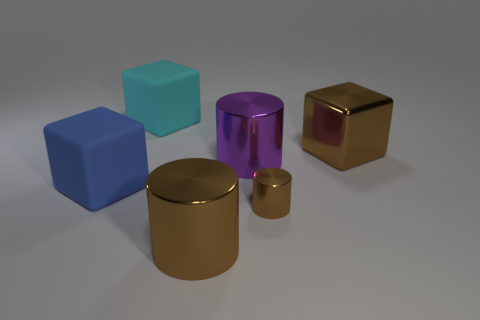How many tiny things are there?
Give a very brief answer. 1. There is a large object behind the big metal cube; is it the same color as the large cube to the right of the large cyan rubber cube?
Provide a short and direct response. No. There is a metallic block that is the same color as the small thing; what is its size?
Keep it short and to the point. Large. How many other objects are the same size as the purple metal cylinder?
Your response must be concise. 4. What color is the big rubber thing that is behind the brown metal cube?
Keep it short and to the point. Cyan. Is the big brown thing in front of the large blue cube made of the same material as the brown block?
Your answer should be compact. Yes. How many things are both to the right of the cyan matte block and on the left side of the shiny block?
Provide a succinct answer. 3. There is a large shiny thing that is in front of the large matte thing that is in front of the big brown metallic cube that is behind the large blue block; what color is it?
Make the answer very short. Brown. What number of other things are there of the same shape as the large cyan matte object?
Ensure brevity in your answer.  2. Are there any cubes that are in front of the large brown metal thing that is right of the big purple metallic object?
Your response must be concise. Yes. 